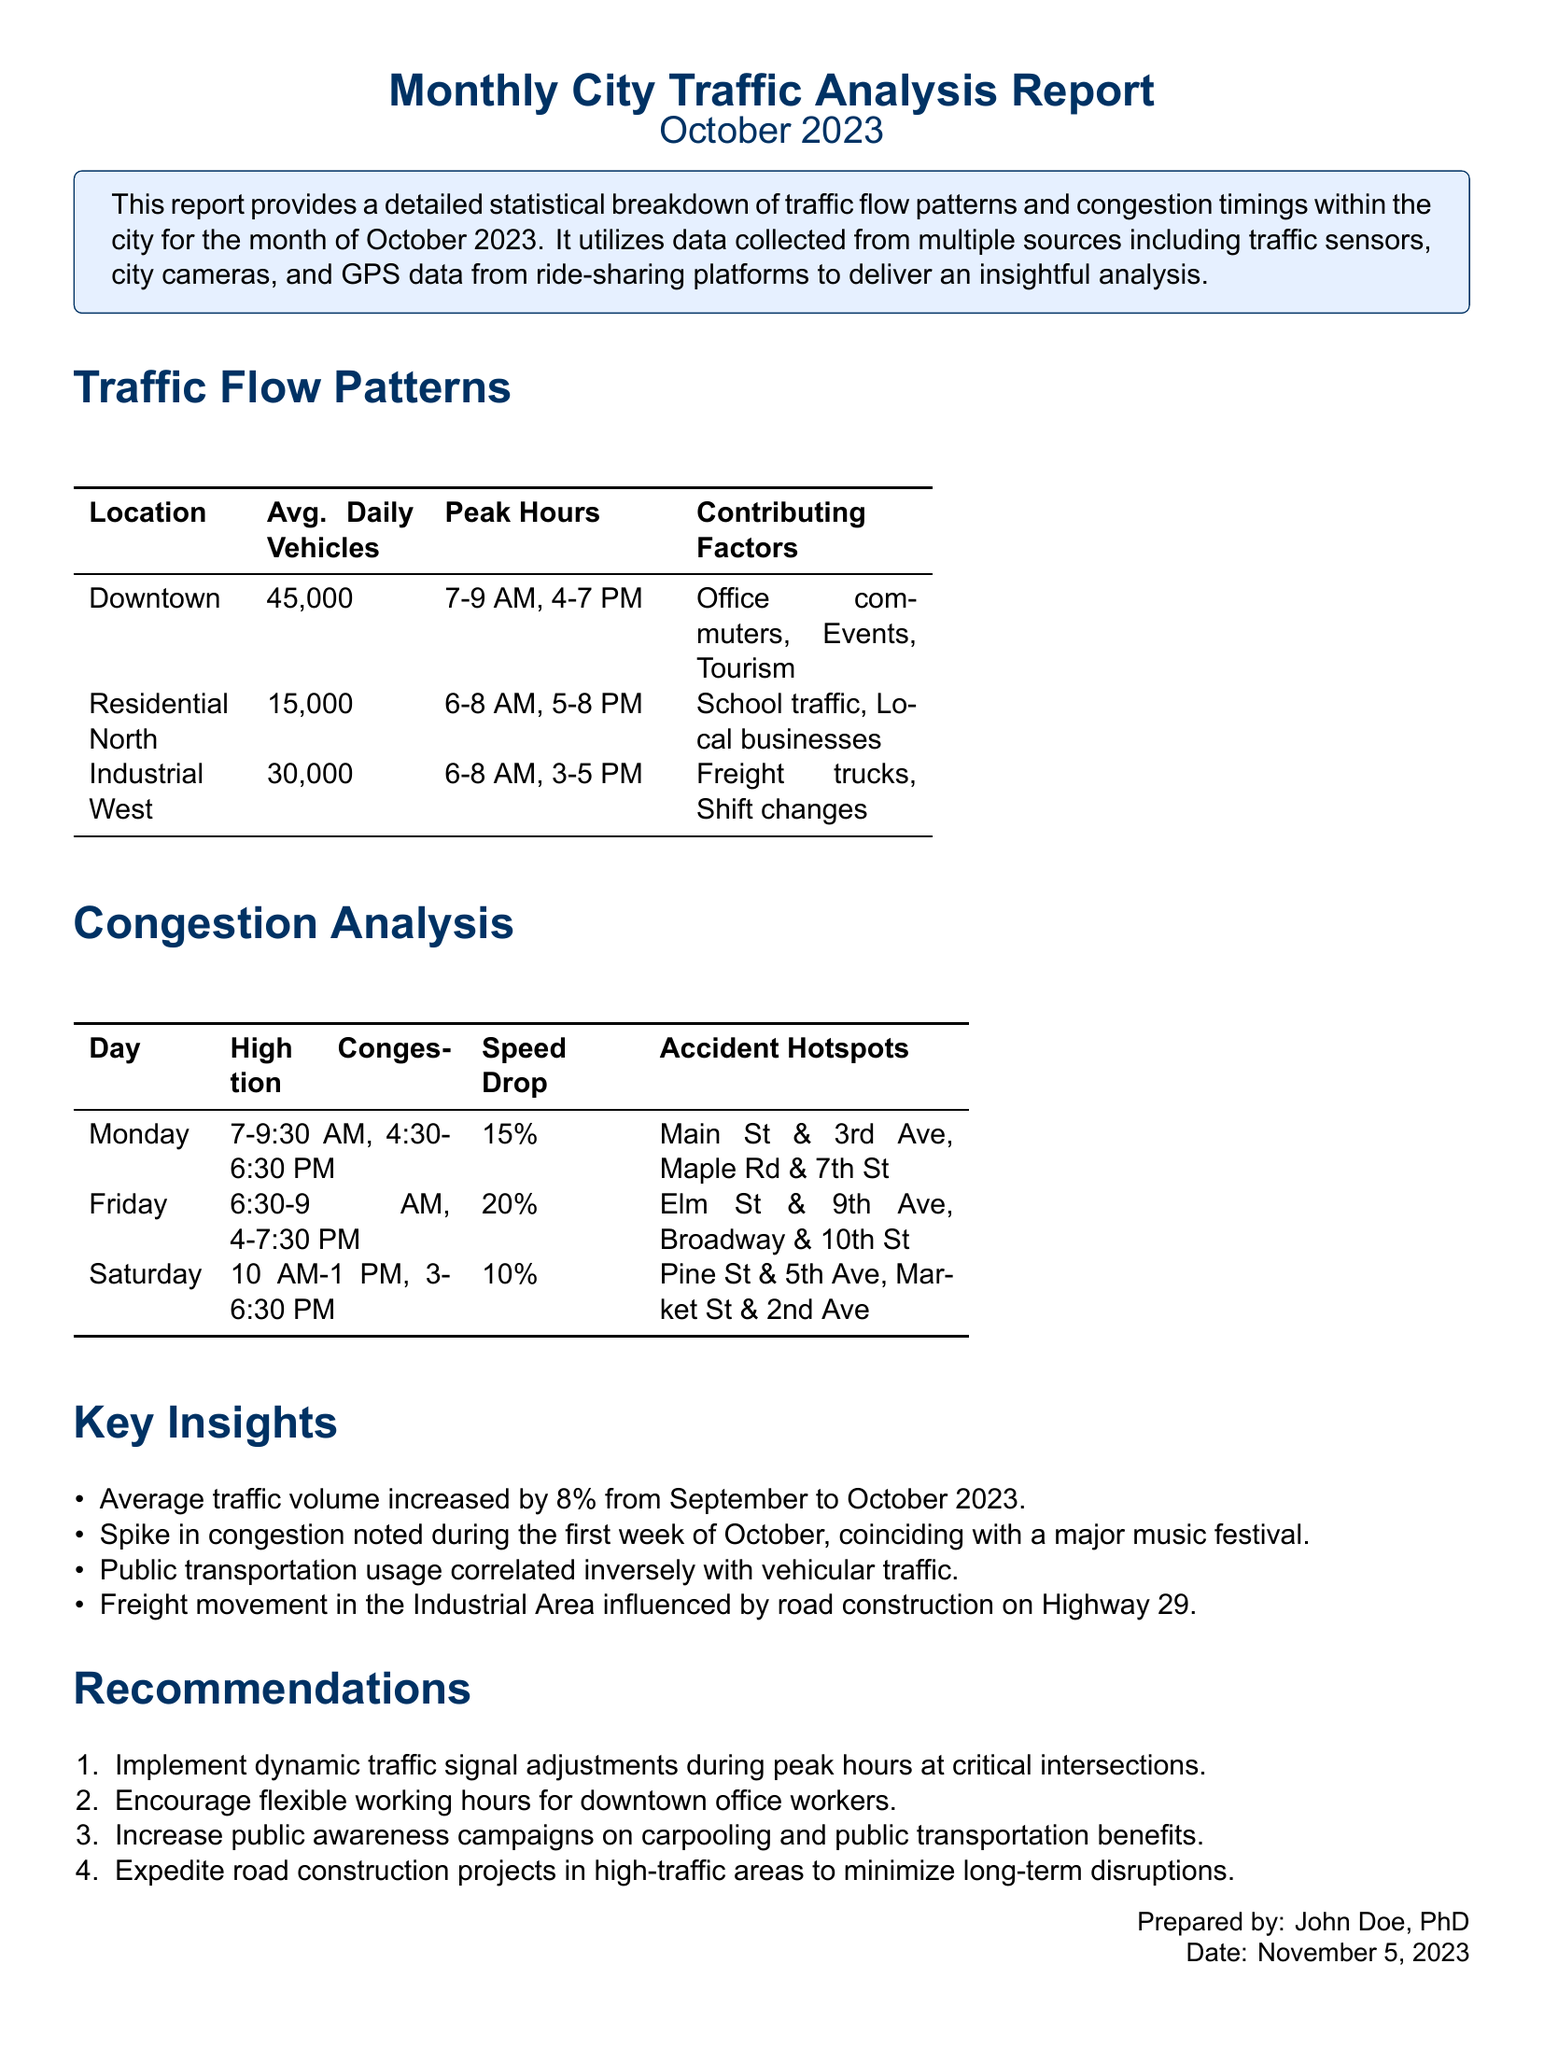what is the average daily number of vehicles in Downtown? The average daily number of vehicles in Downtown is listed in the Traffic Flow Patterns section of the report.
Answer: 45,000 what time interval shows high congestion on Fridays? The high congestion intervals on Fridays are detailed in the Congestion Analysis section, focusing on specific times.
Answer: 6:30-9 AM, 4-7:30 PM which factor contributes to traffic in the Residential North area? Contributing factors for traffic flow are mentioned in the Traffic Flow Patterns section, relating to the specific area.
Answer: School traffic, Local businesses what percentage did average traffic volume increase from September to October 2023? The percentage increase is summarized in the Key Insights section of the report.
Answer: 8% what is one recommendation for addressing traffic congestion? Recommendations to alleviate congestion are provided, focusing on traffic management and public awareness.
Answer: Implement dynamic traffic signal adjustments during peak hours which day saw the highest congestion in the morning during October? The days with high congestion are outlined in the Congestion Analysis section.
Answer: Monday what location has the highest average daily vehicle count? The average vehicle counts for various locations are presented in the Traffic Flow Patterns table.
Answer: Downtown what is a suggested action to improve public transportation usage? Suggestions for improving traffic flow include actions related to public behavior and transport usage mentioned in the Recommendations section.
Answer: Increase public awareness campaigns on carpooling and public transportation benefits 